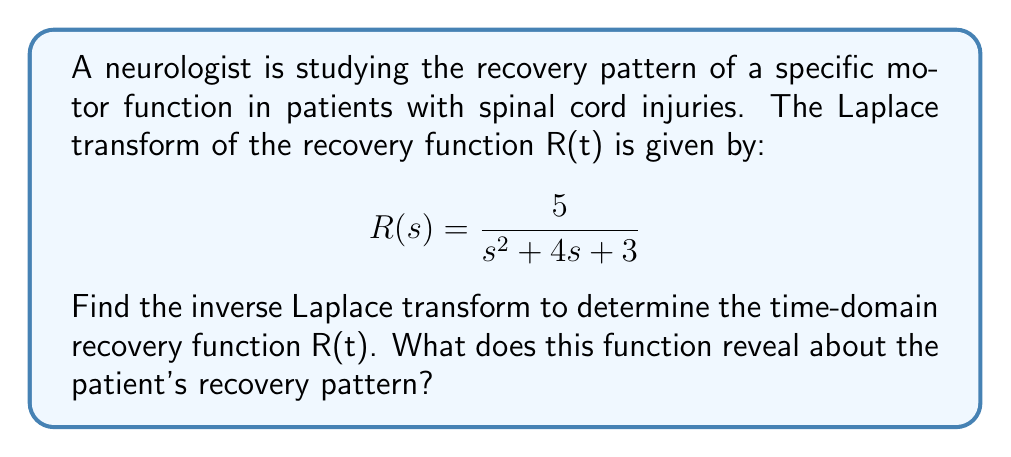Help me with this question. To find the inverse Laplace transform, we need to follow these steps:

1) First, we recognize that the given Laplace transform is in the form:

   $$\frac{A}{s^2 + 2as + b^2}$$

   where $A = 5$, $2a = 4$ (so $a = 2$), and $b^2 = 3$.

2) The inverse Laplace transform of this form is:

   $$A\frac{e^{-at}}{\sqrt{b^2-a^2}}\sin(\sqrt{b^2-a^2}t)$$

3) We need to calculate $\sqrt{b^2-a^2}$:
   
   $b^2 = 3$, so $b = \sqrt{3}$
   $\sqrt{b^2-a^2} = \sqrt{3-2^2} = \sqrt{3-4} = \sqrt{-1} = i$

4) Substituting these values into the formula:

   $$R(t) = 5\frac{e^{-2t}}{\sqrt{3-4}}\sin(\sqrt{3-4}t) = 5e^{-2t}\sin(it)$$

5) Using Euler's formula, we can simplify this further:

   $$\sin(it) = \frac{e^{it} - e^{-it}}{2i} = \frac{e^t - e^{-t}}{2}$$

6) Therefore, our final recovery function is:

   $$R(t) = \frac{5}{2}(e^{-t} - e^{-3t})$$

This function reveals that the recovery pattern is characterized by two exponential terms:
- A slower recovery component ($e^{-t}$) that decays gradually
- A faster recovery component ($e^{-3t}$) that decays more rapidly

The overall recovery is the difference between these two components, suggesting an initial rapid improvement followed by a more gradual long-term recovery.
Answer: $$R(t) = \frac{5}{2}(e^{-t} - e^{-3t})$$ 